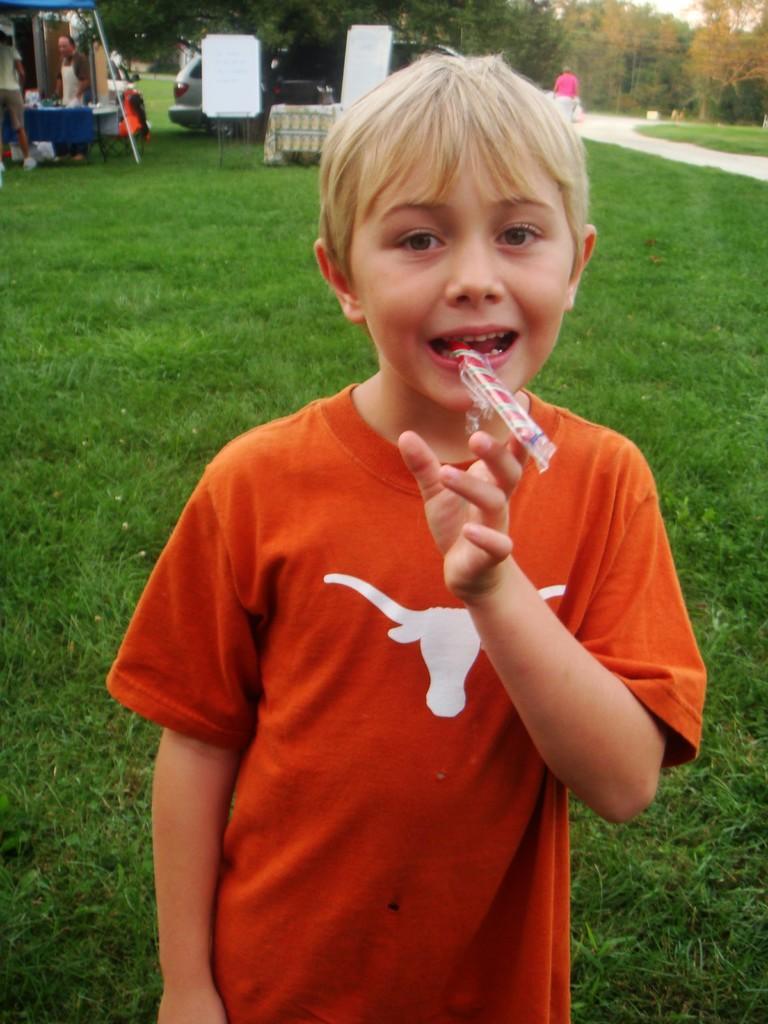Could you give a brief overview of what you see in this image? In this picture I can see there is a boy standing and wearing a orange color shirt and he is holding something in the mouth and there is walkway to right and there is a person walking, there is grass on the floor and there are two people standing in the backdrop on left, there are boards, trees and a car. 